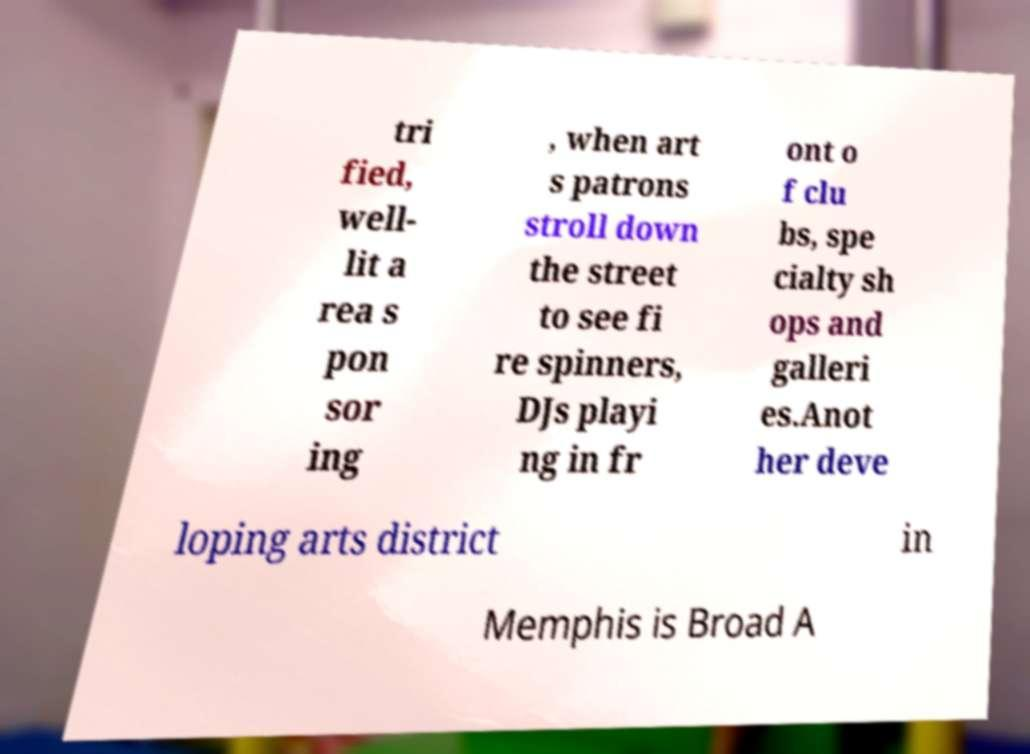What messages or text are displayed in this image? I need them in a readable, typed format. tri fied, well- lit a rea s pon sor ing , when art s patrons stroll down the street to see fi re spinners, DJs playi ng in fr ont o f clu bs, spe cialty sh ops and galleri es.Anot her deve loping arts district in Memphis is Broad A 